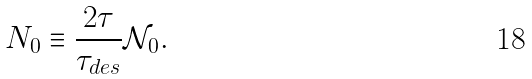<formula> <loc_0><loc_0><loc_500><loc_500>N _ { 0 } \equiv \frac { 2 \tau } { \tau _ { d e s } } \mathcal { N } _ { 0 } .</formula> 